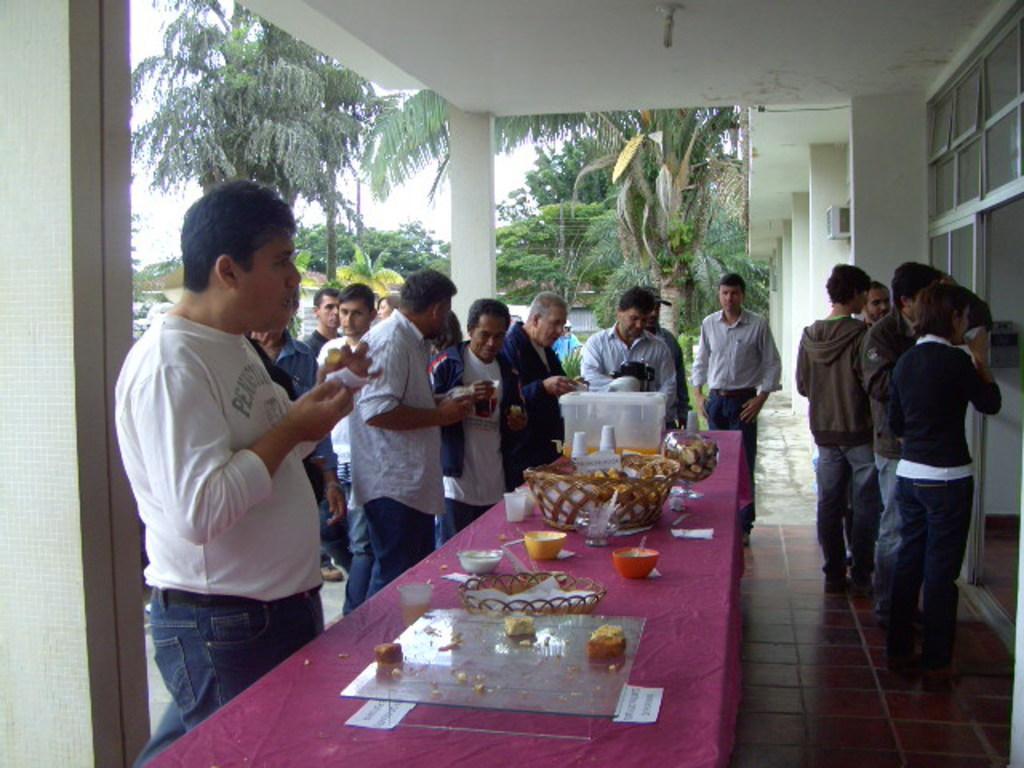Describe this image in one or two sentences. In the image there are many people outside the house it looks like a party there is a big table,on the table that is a pink the cloth on that there are some food items kept,so the people are eating the food,in the background there is a building,some trees and sky. 